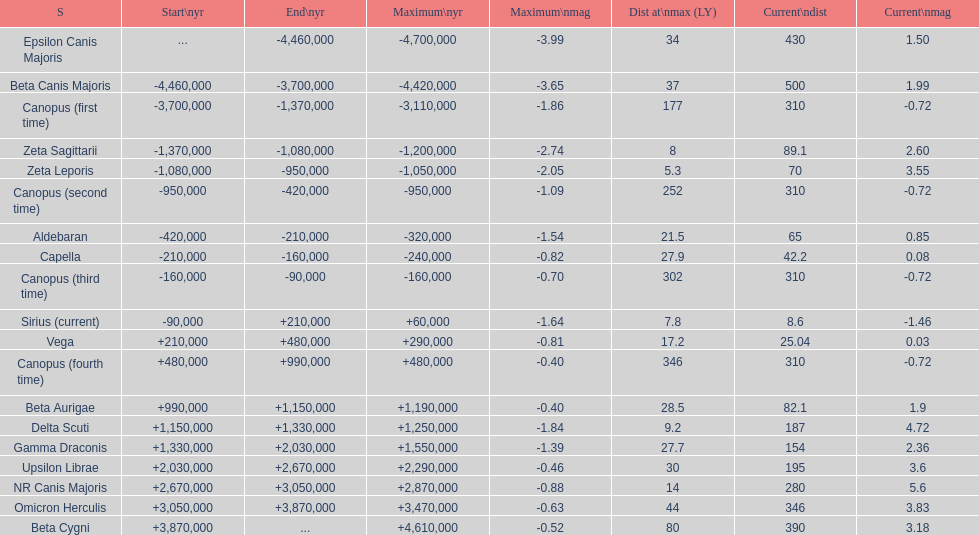What is the number of stars that have a maximum magnitude less than zero? 5. 